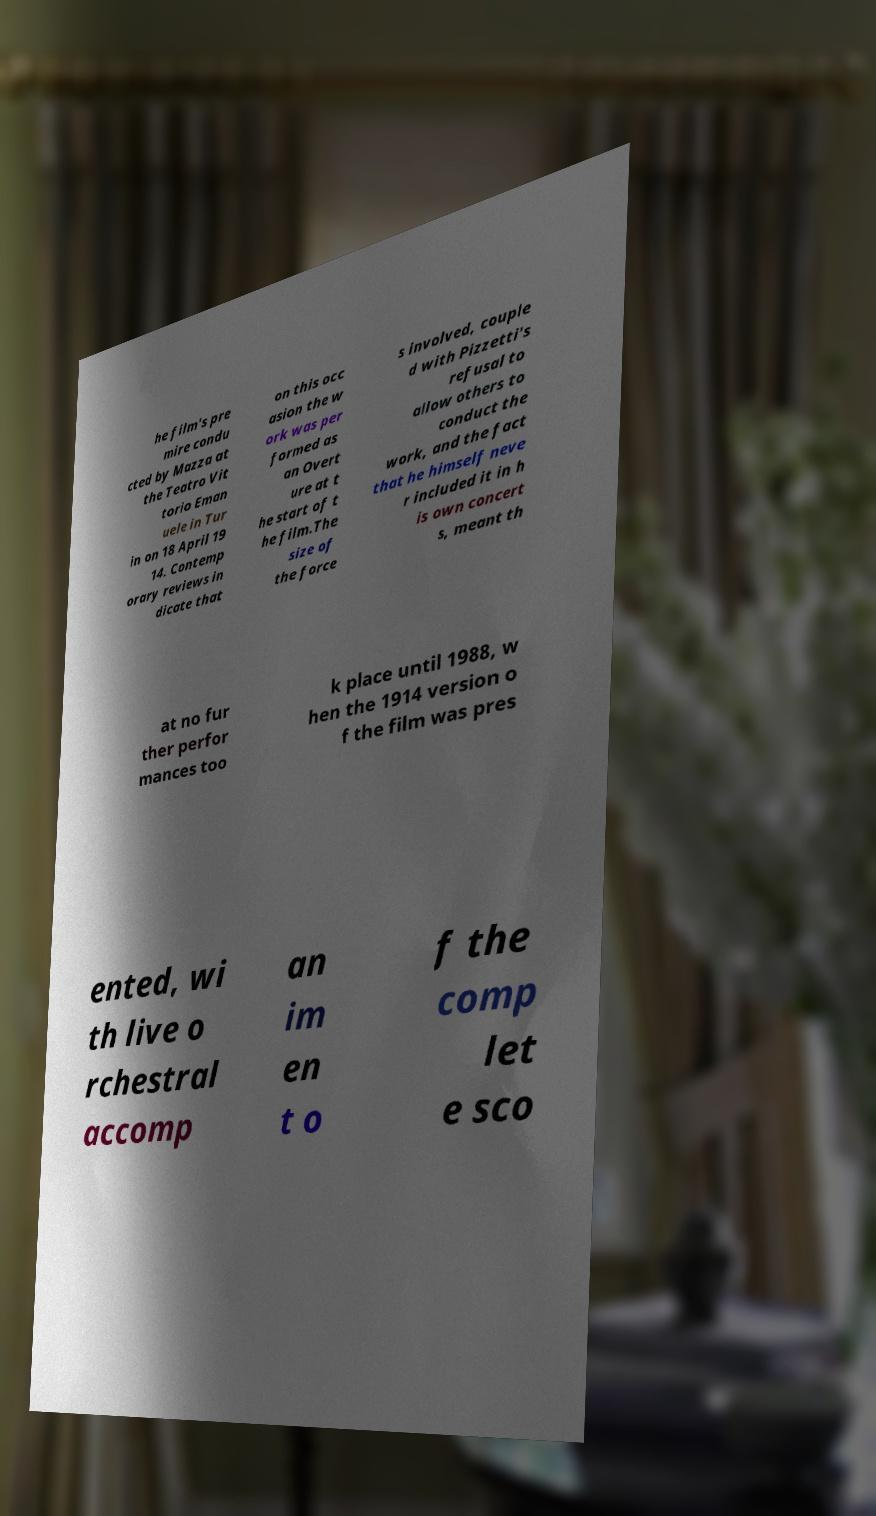I need the written content from this picture converted into text. Can you do that? he film's pre mire condu cted by Mazza at the Teatro Vit torio Eman uele in Tur in on 18 April 19 14. Contemp orary reviews in dicate that on this occ asion the w ork was per formed as an Overt ure at t he start of t he film.The size of the force s involved, couple d with Pizzetti's refusal to allow others to conduct the work, and the fact that he himself neve r included it in h is own concert s, meant th at no fur ther perfor mances too k place until 1988, w hen the 1914 version o f the film was pres ented, wi th live o rchestral accomp an im en t o f the comp let e sco 